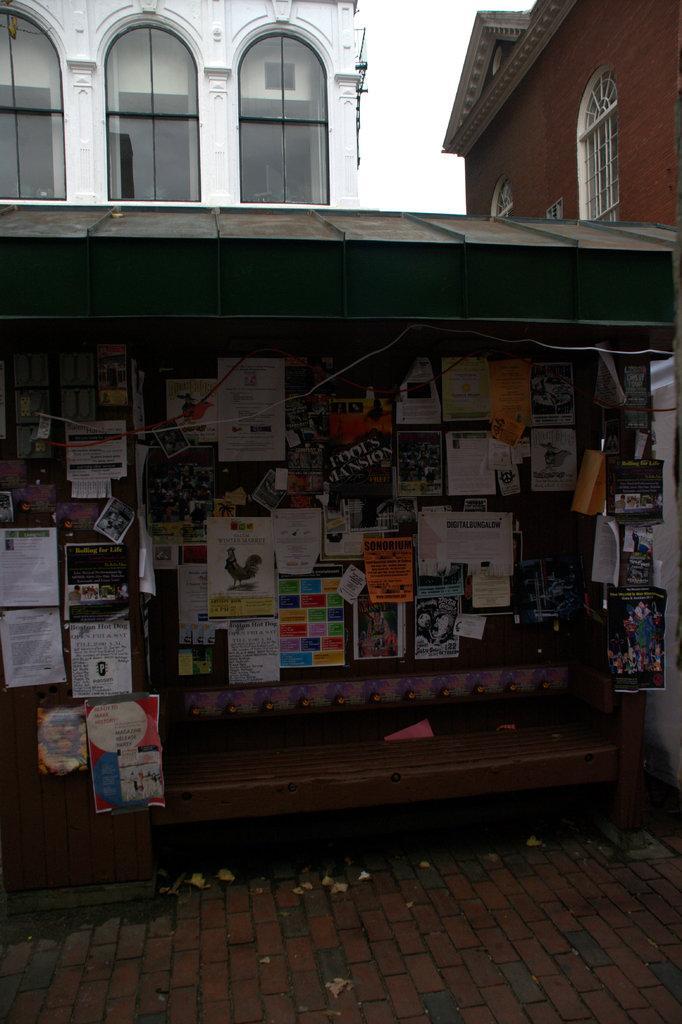Could you give a brief overview of what you see in this image? In this image in the center there is a wall, on the wall there are some posters and one bench. In the background there are some buildings, at the bottom there is a walkway. 